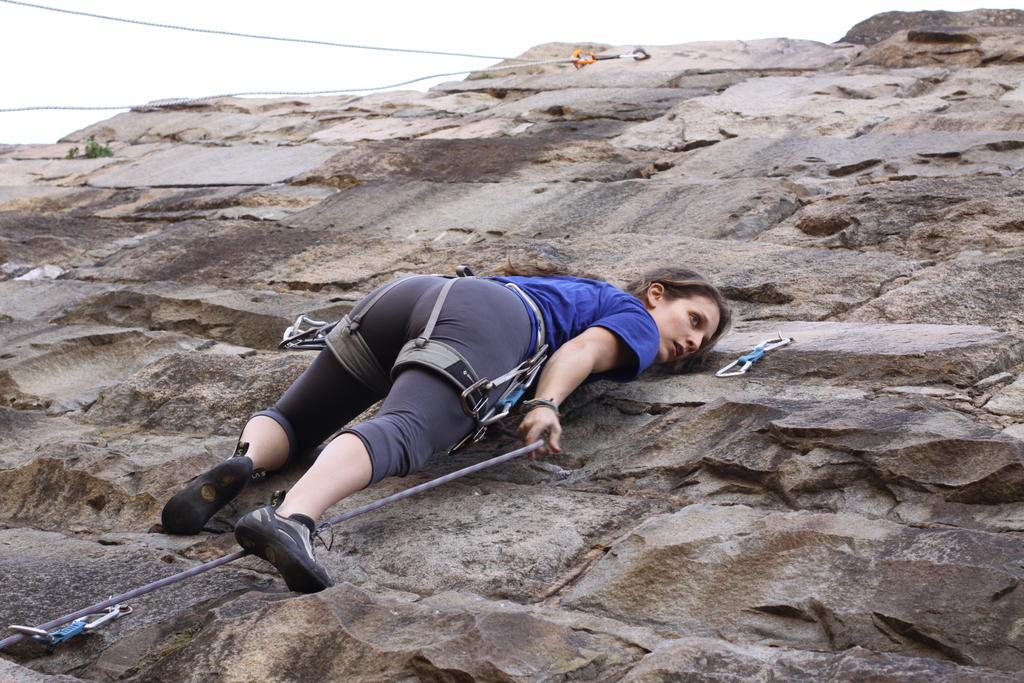Who is the main subject in the image? There is a woman in the image. What is the woman doing in the image? The woman is climbing a wall. What tools might the woman be using to assist her in climbing the wall? Ropes are visible in the image, which might be used by the woman to assist her in climbing the wall. What can be seen in the background of the image? The sky is visible in the image. What type of science experiment can be seen being conducted in the image? There is no science experiment present in the image; it features a woman climbing a wall with ropes. How many geese are visible in the image? There are no geese present in the image. 